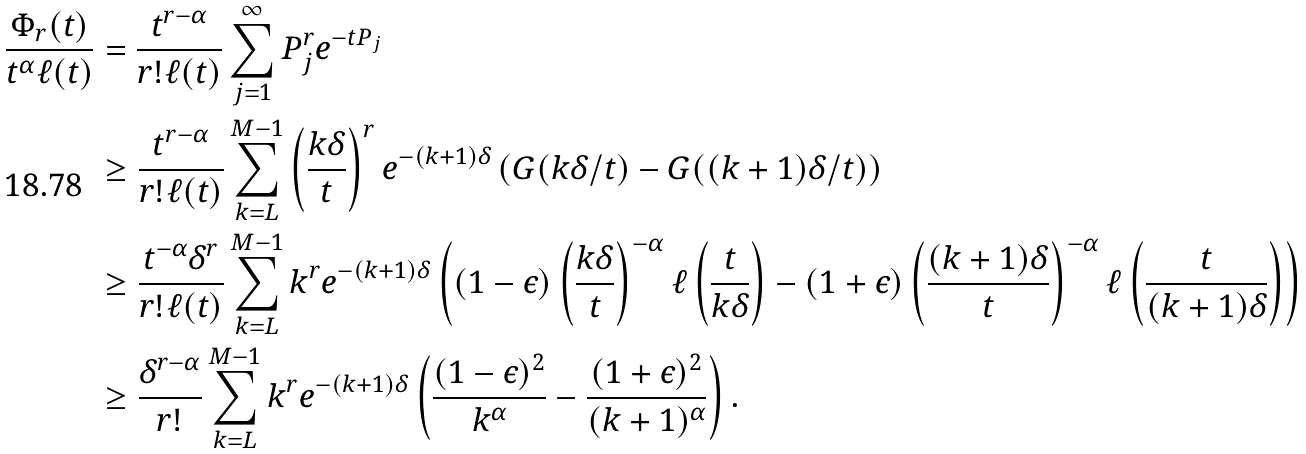<formula> <loc_0><loc_0><loc_500><loc_500>\frac { \Phi _ { r } ( t ) } { t ^ { \alpha } \ell ( t ) } & = \frac { t ^ { r - \alpha } } { r ! \ell ( t ) } \sum _ { j = 1 } ^ { \infty } P _ { j } ^ { r } e ^ { - t P _ { j } } \\ & \geq \frac { t ^ { r - \alpha } } { r ! \ell ( t ) } \sum _ { k = L } ^ { M - 1 } \left ( \frac { k \delta } { t } \right ) ^ { r } e ^ { - ( k + 1 ) \delta } \left ( G ( k \delta / t ) - G ( ( k + 1 ) \delta / t ) \right ) \\ & \geq \frac { t ^ { - \alpha } \delta ^ { r } } { r ! \ell ( t ) } \sum _ { k = L } ^ { M - 1 } k ^ { r } e ^ { - ( k + 1 ) \delta } \left ( ( 1 - \epsilon ) \left ( \frac { k \delta } { t } \right ) ^ { - \alpha } \ell \left ( \frac { t } { k \delta } \right ) - ( 1 + \epsilon ) \left ( \frac { ( k + 1 ) \delta } { t } \right ) ^ { - \alpha } \ell \left ( \frac { t } { ( k + 1 ) \delta } \right ) \right ) \\ & \geq \frac { \delta ^ { r - \alpha } } { r ! } \sum _ { k = L } ^ { M - 1 } k ^ { r } e ^ { - ( k + 1 ) \delta } \left ( \frac { ( 1 - \epsilon ) ^ { 2 } } { k ^ { \alpha } } - \frac { ( 1 + \epsilon ) ^ { 2 } } { ( k + 1 ) ^ { \alpha } } \right ) .</formula> 